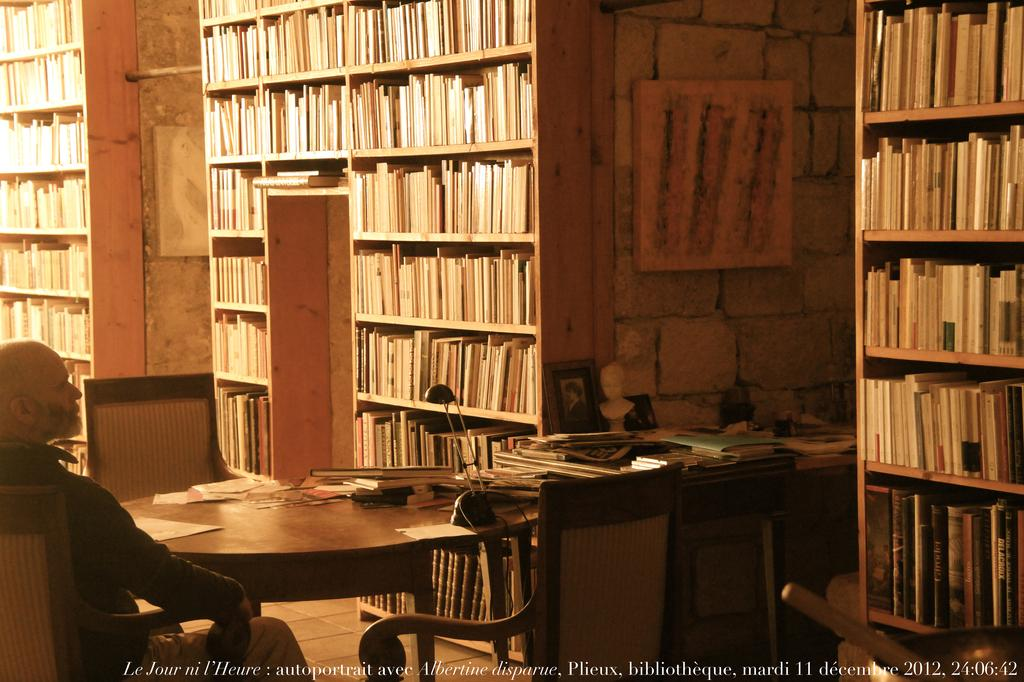Provide a one-sentence caption for the provided image. A middle aged man is sitting at a round table, in a library on December 11, 2012. 